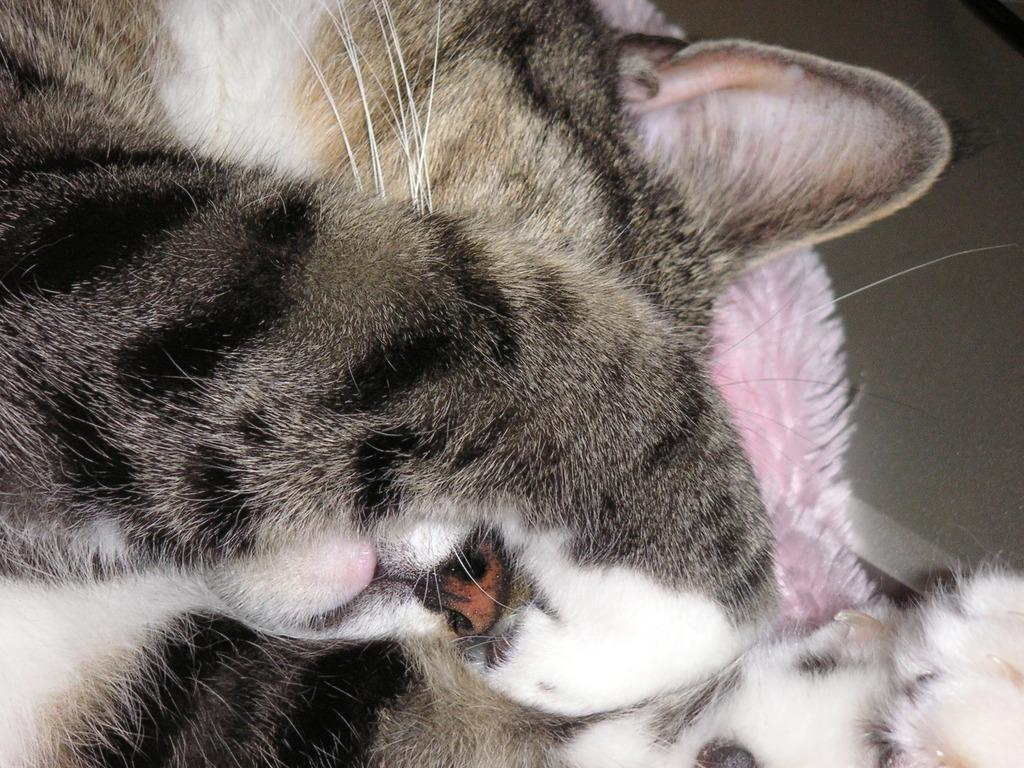What animal is in the image? There is a cat in the image. Where is the cat located in the image? The cat is in the middle of the image. What other object can be seen in the image? There is a cloth in the image. What color is the cloth? The cloth is pink in color. Where is the cloth located in the image? The cloth is on the floor. How many pigs are playing with the jewel in the image? There are no pigs or jewels present in the image. 